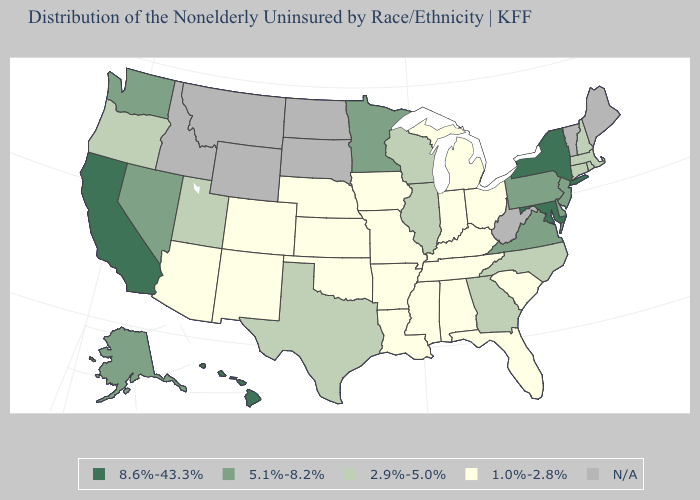What is the value of South Carolina?
Be succinct. 1.0%-2.8%. Among the states that border Wisconsin , does Minnesota have the highest value?
Give a very brief answer. Yes. Name the states that have a value in the range 1.0%-2.8%?
Keep it brief. Alabama, Arizona, Arkansas, Colorado, Florida, Indiana, Iowa, Kansas, Kentucky, Louisiana, Michigan, Mississippi, Missouri, Nebraska, New Mexico, Ohio, Oklahoma, South Carolina, Tennessee. Which states hav the highest value in the Northeast?
Keep it brief. New York. Name the states that have a value in the range 1.0%-2.8%?
Short answer required. Alabama, Arizona, Arkansas, Colorado, Florida, Indiana, Iowa, Kansas, Kentucky, Louisiana, Michigan, Mississippi, Missouri, Nebraska, New Mexico, Ohio, Oklahoma, South Carolina, Tennessee. What is the value of Kansas?
Concise answer only. 1.0%-2.8%. What is the value of Hawaii?
Give a very brief answer. 8.6%-43.3%. Which states have the lowest value in the MidWest?
Be succinct. Indiana, Iowa, Kansas, Michigan, Missouri, Nebraska, Ohio. Among the states that border Oregon , which have the lowest value?
Keep it brief. Nevada, Washington. Name the states that have a value in the range 2.9%-5.0%?
Write a very short answer. Connecticut, Georgia, Illinois, Massachusetts, New Hampshire, North Carolina, Oregon, Rhode Island, Texas, Utah, Wisconsin. What is the lowest value in states that border Kentucky?
Quick response, please. 1.0%-2.8%. Name the states that have a value in the range 2.9%-5.0%?
Concise answer only. Connecticut, Georgia, Illinois, Massachusetts, New Hampshire, North Carolina, Oregon, Rhode Island, Texas, Utah, Wisconsin. Among the states that border Oklahoma , does Missouri have the highest value?
Quick response, please. No. Name the states that have a value in the range N/A?
Keep it brief. Idaho, Maine, Montana, North Dakota, South Dakota, Vermont, West Virginia, Wyoming. Name the states that have a value in the range 2.9%-5.0%?
Write a very short answer. Connecticut, Georgia, Illinois, Massachusetts, New Hampshire, North Carolina, Oregon, Rhode Island, Texas, Utah, Wisconsin. 